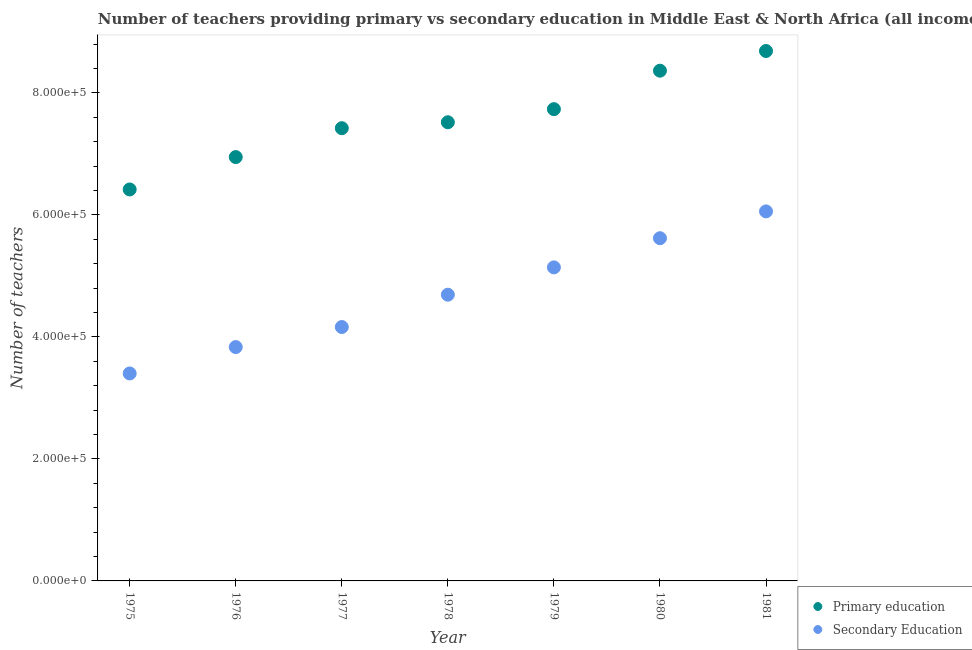Is the number of dotlines equal to the number of legend labels?
Offer a very short reply. Yes. What is the number of secondary teachers in 1978?
Keep it short and to the point. 4.69e+05. Across all years, what is the maximum number of primary teachers?
Ensure brevity in your answer.  8.69e+05. Across all years, what is the minimum number of primary teachers?
Keep it short and to the point. 6.42e+05. In which year was the number of secondary teachers maximum?
Offer a very short reply. 1981. In which year was the number of secondary teachers minimum?
Your answer should be compact. 1975. What is the total number of secondary teachers in the graph?
Your answer should be very brief. 3.29e+06. What is the difference between the number of primary teachers in 1977 and that in 1981?
Offer a terse response. -1.27e+05. What is the difference between the number of secondary teachers in 1980 and the number of primary teachers in 1977?
Ensure brevity in your answer.  -1.80e+05. What is the average number of primary teachers per year?
Give a very brief answer. 7.59e+05. In the year 1975, what is the difference between the number of secondary teachers and number of primary teachers?
Provide a short and direct response. -3.02e+05. In how many years, is the number of primary teachers greater than 560000?
Ensure brevity in your answer.  7. What is the ratio of the number of primary teachers in 1976 to that in 1979?
Provide a short and direct response. 0.9. Is the difference between the number of secondary teachers in 1979 and 1980 greater than the difference between the number of primary teachers in 1979 and 1980?
Provide a succinct answer. Yes. What is the difference between the highest and the second highest number of primary teachers?
Give a very brief answer. 3.23e+04. What is the difference between the highest and the lowest number of secondary teachers?
Your response must be concise. 2.66e+05. How many years are there in the graph?
Your answer should be compact. 7. Are the values on the major ticks of Y-axis written in scientific E-notation?
Your answer should be very brief. Yes. Where does the legend appear in the graph?
Offer a very short reply. Bottom right. How are the legend labels stacked?
Offer a very short reply. Vertical. What is the title of the graph?
Make the answer very short. Number of teachers providing primary vs secondary education in Middle East & North Africa (all income levels). What is the label or title of the X-axis?
Your response must be concise. Year. What is the label or title of the Y-axis?
Your answer should be very brief. Number of teachers. What is the Number of teachers in Primary education in 1975?
Keep it short and to the point. 6.42e+05. What is the Number of teachers in Secondary Education in 1975?
Keep it short and to the point. 3.40e+05. What is the Number of teachers in Primary education in 1976?
Offer a terse response. 6.95e+05. What is the Number of teachers in Secondary Education in 1976?
Your answer should be compact. 3.83e+05. What is the Number of teachers in Primary education in 1977?
Give a very brief answer. 7.42e+05. What is the Number of teachers of Secondary Education in 1977?
Ensure brevity in your answer.  4.16e+05. What is the Number of teachers of Primary education in 1978?
Provide a succinct answer. 7.52e+05. What is the Number of teachers in Secondary Education in 1978?
Your answer should be very brief. 4.69e+05. What is the Number of teachers of Primary education in 1979?
Offer a very short reply. 7.73e+05. What is the Number of teachers in Secondary Education in 1979?
Offer a terse response. 5.14e+05. What is the Number of teachers of Primary education in 1980?
Ensure brevity in your answer.  8.37e+05. What is the Number of teachers of Secondary Education in 1980?
Your answer should be very brief. 5.62e+05. What is the Number of teachers of Primary education in 1981?
Provide a short and direct response. 8.69e+05. What is the Number of teachers of Secondary Education in 1981?
Make the answer very short. 6.06e+05. Across all years, what is the maximum Number of teachers in Primary education?
Give a very brief answer. 8.69e+05. Across all years, what is the maximum Number of teachers of Secondary Education?
Make the answer very short. 6.06e+05. Across all years, what is the minimum Number of teachers in Primary education?
Offer a very short reply. 6.42e+05. Across all years, what is the minimum Number of teachers in Secondary Education?
Keep it short and to the point. 3.40e+05. What is the total Number of teachers in Primary education in the graph?
Give a very brief answer. 5.31e+06. What is the total Number of teachers in Secondary Education in the graph?
Offer a very short reply. 3.29e+06. What is the difference between the Number of teachers in Primary education in 1975 and that in 1976?
Your response must be concise. -5.31e+04. What is the difference between the Number of teachers of Secondary Education in 1975 and that in 1976?
Your answer should be compact. -4.32e+04. What is the difference between the Number of teachers in Primary education in 1975 and that in 1977?
Provide a succinct answer. -1.00e+05. What is the difference between the Number of teachers in Secondary Education in 1975 and that in 1977?
Ensure brevity in your answer.  -7.61e+04. What is the difference between the Number of teachers in Primary education in 1975 and that in 1978?
Your answer should be very brief. -1.10e+05. What is the difference between the Number of teachers of Secondary Education in 1975 and that in 1978?
Give a very brief answer. -1.29e+05. What is the difference between the Number of teachers in Primary education in 1975 and that in 1979?
Offer a very short reply. -1.32e+05. What is the difference between the Number of teachers in Secondary Education in 1975 and that in 1979?
Your answer should be compact. -1.74e+05. What is the difference between the Number of teachers in Primary education in 1975 and that in 1980?
Your response must be concise. -1.95e+05. What is the difference between the Number of teachers of Secondary Education in 1975 and that in 1980?
Provide a succinct answer. -2.22e+05. What is the difference between the Number of teachers of Primary education in 1975 and that in 1981?
Provide a succinct answer. -2.27e+05. What is the difference between the Number of teachers in Secondary Education in 1975 and that in 1981?
Give a very brief answer. -2.66e+05. What is the difference between the Number of teachers in Primary education in 1976 and that in 1977?
Make the answer very short. -4.74e+04. What is the difference between the Number of teachers of Secondary Education in 1976 and that in 1977?
Offer a terse response. -3.29e+04. What is the difference between the Number of teachers of Primary education in 1976 and that in 1978?
Make the answer very short. -5.71e+04. What is the difference between the Number of teachers of Secondary Education in 1976 and that in 1978?
Your answer should be very brief. -8.59e+04. What is the difference between the Number of teachers in Primary education in 1976 and that in 1979?
Your answer should be very brief. -7.86e+04. What is the difference between the Number of teachers in Secondary Education in 1976 and that in 1979?
Make the answer very short. -1.31e+05. What is the difference between the Number of teachers of Primary education in 1976 and that in 1980?
Provide a short and direct response. -1.42e+05. What is the difference between the Number of teachers in Secondary Education in 1976 and that in 1980?
Your answer should be very brief. -1.78e+05. What is the difference between the Number of teachers in Primary education in 1976 and that in 1981?
Your answer should be compact. -1.74e+05. What is the difference between the Number of teachers in Secondary Education in 1976 and that in 1981?
Your answer should be compact. -2.22e+05. What is the difference between the Number of teachers in Primary education in 1977 and that in 1978?
Ensure brevity in your answer.  -9722.06. What is the difference between the Number of teachers of Secondary Education in 1977 and that in 1978?
Ensure brevity in your answer.  -5.30e+04. What is the difference between the Number of teachers in Primary education in 1977 and that in 1979?
Ensure brevity in your answer.  -3.12e+04. What is the difference between the Number of teachers in Secondary Education in 1977 and that in 1979?
Offer a terse response. -9.78e+04. What is the difference between the Number of teachers of Primary education in 1977 and that in 1980?
Make the answer very short. -9.43e+04. What is the difference between the Number of teachers in Secondary Education in 1977 and that in 1980?
Keep it short and to the point. -1.46e+05. What is the difference between the Number of teachers of Primary education in 1977 and that in 1981?
Keep it short and to the point. -1.27e+05. What is the difference between the Number of teachers of Secondary Education in 1977 and that in 1981?
Provide a succinct answer. -1.90e+05. What is the difference between the Number of teachers of Primary education in 1978 and that in 1979?
Your answer should be compact. -2.15e+04. What is the difference between the Number of teachers in Secondary Education in 1978 and that in 1979?
Keep it short and to the point. -4.48e+04. What is the difference between the Number of teachers of Primary education in 1978 and that in 1980?
Your response must be concise. -8.45e+04. What is the difference between the Number of teachers of Secondary Education in 1978 and that in 1980?
Your response must be concise. -9.26e+04. What is the difference between the Number of teachers in Primary education in 1978 and that in 1981?
Offer a terse response. -1.17e+05. What is the difference between the Number of teachers of Secondary Education in 1978 and that in 1981?
Keep it short and to the point. -1.37e+05. What is the difference between the Number of teachers in Primary education in 1979 and that in 1980?
Your answer should be very brief. -6.31e+04. What is the difference between the Number of teachers in Secondary Education in 1979 and that in 1980?
Make the answer very short. -4.78e+04. What is the difference between the Number of teachers in Primary education in 1979 and that in 1981?
Keep it short and to the point. -9.54e+04. What is the difference between the Number of teachers of Secondary Education in 1979 and that in 1981?
Make the answer very short. -9.18e+04. What is the difference between the Number of teachers in Primary education in 1980 and that in 1981?
Offer a very short reply. -3.23e+04. What is the difference between the Number of teachers in Secondary Education in 1980 and that in 1981?
Your response must be concise. -4.40e+04. What is the difference between the Number of teachers of Primary education in 1975 and the Number of teachers of Secondary Education in 1976?
Your answer should be very brief. 2.58e+05. What is the difference between the Number of teachers in Primary education in 1975 and the Number of teachers in Secondary Education in 1977?
Offer a very short reply. 2.26e+05. What is the difference between the Number of teachers of Primary education in 1975 and the Number of teachers of Secondary Education in 1978?
Your answer should be compact. 1.73e+05. What is the difference between the Number of teachers in Primary education in 1975 and the Number of teachers in Secondary Education in 1979?
Provide a short and direct response. 1.28e+05. What is the difference between the Number of teachers of Primary education in 1975 and the Number of teachers of Secondary Education in 1980?
Your answer should be compact. 8.00e+04. What is the difference between the Number of teachers in Primary education in 1975 and the Number of teachers in Secondary Education in 1981?
Provide a succinct answer. 3.60e+04. What is the difference between the Number of teachers in Primary education in 1976 and the Number of teachers in Secondary Education in 1977?
Your answer should be very brief. 2.79e+05. What is the difference between the Number of teachers of Primary education in 1976 and the Number of teachers of Secondary Education in 1978?
Offer a very short reply. 2.26e+05. What is the difference between the Number of teachers of Primary education in 1976 and the Number of teachers of Secondary Education in 1979?
Make the answer very short. 1.81e+05. What is the difference between the Number of teachers of Primary education in 1976 and the Number of teachers of Secondary Education in 1980?
Ensure brevity in your answer.  1.33e+05. What is the difference between the Number of teachers of Primary education in 1976 and the Number of teachers of Secondary Education in 1981?
Provide a succinct answer. 8.91e+04. What is the difference between the Number of teachers in Primary education in 1977 and the Number of teachers in Secondary Education in 1978?
Your answer should be compact. 2.73e+05. What is the difference between the Number of teachers of Primary education in 1977 and the Number of teachers of Secondary Education in 1979?
Make the answer very short. 2.28e+05. What is the difference between the Number of teachers of Primary education in 1977 and the Number of teachers of Secondary Education in 1980?
Your answer should be compact. 1.80e+05. What is the difference between the Number of teachers in Primary education in 1977 and the Number of teachers in Secondary Education in 1981?
Provide a short and direct response. 1.36e+05. What is the difference between the Number of teachers of Primary education in 1978 and the Number of teachers of Secondary Education in 1979?
Your answer should be very brief. 2.38e+05. What is the difference between the Number of teachers in Primary education in 1978 and the Number of teachers in Secondary Education in 1980?
Your response must be concise. 1.90e+05. What is the difference between the Number of teachers in Primary education in 1978 and the Number of teachers in Secondary Education in 1981?
Your response must be concise. 1.46e+05. What is the difference between the Number of teachers of Primary education in 1979 and the Number of teachers of Secondary Education in 1980?
Make the answer very short. 2.12e+05. What is the difference between the Number of teachers of Primary education in 1979 and the Number of teachers of Secondary Education in 1981?
Make the answer very short. 1.68e+05. What is the difference between the Number of teachers in Primary education in 1980 and the Number of teachers in Secondary Education in 1981?
Keep it short and to the point. 2.31e+05. What is the average Number of teachers of Primary education per year?
Your response must be concise. 7.59e+05. What is the average Number of teachers of Secondary Education per year?
Offer a very short reply. 4.70e+05. In the year 1975, what is the difference between the Number of teachers in Primary education and Number of teachers in Secondary Education?
Keep it short and to the point. 3.02e+05. In the year 1976, what is the difference between the Number of teachers of Primary education and Number of teachers of Secondary Education?
Offer a very short reply. 3.12e+05. In the year 1977, what is the difference between the Number of teachers in Primary education and Number of teachers in Secondary Education?
Give a very brief answer. 3.26e+05. In the year 1978, what is the difference between the Number of teachers in Primary education and Number of teachers in Secondary Education?
Make the answer very short. 2.83e+05. In the year 1979, what is the difference between the Number of teachers of Primary education and Number of teachers of Secondary Education?
Offer a terse response. 2.59e+05. In the year 1980, what is the difference between the Number of teachers of Primary education and Number of teachers of Secondary Education?
Provide a short and direct response. 2.75e+05. In the year 1981, what is the difference between the Number of teachers in Primary education and Number of teachers in Secondary Education?
Offer a very short reply. 2.63e+05. What is the ratio of the Number of teachers in Primary education in 1975 to that in 1976?
Ensure brevity in your answer.  0.92. What is the ratio of the Number of teachers in Secondary Education in 1975 to that in 1976?
Your answer should be compact. 0.89. What is the ratio of the Number of teachers of Primary education in 1975 to that in 1977?
Your answer should be very brief. 0.86. What is the ratio of the Number of teachers of Secondary Education in 1975 to that in 1977?
Your answer should be compact. 0.82. What is the ratio of the Number of teachers in Primary education in 1975 to that in 1978?
Keep it short and to the point. 0.85. What is the ratio of the Number of teachers of Secondary Education in 1975 to that in 1978?
Your answer should be compact. 0.72. What is the ratio of the Number of teachers in Primary education in 1975 to that in 1979?
Offer a terse response. 0.83. What is the ratio of the Number of teachers in Secondary Education in 1975 to that in 1979?
Your response must be concise. 0.66. What is the ratio of the Number of teachers of Primary education in 1975 to that in 1980?
Keep it short and to the point. 0.77. What is the ratio of the Number of teachers of Secondary Education in 1975 to that in 1980?
Ensure brevity in your answer.  0.61. What is the ratio of the Number of teachers of Primary education in 1975 to that in 1981?
Offer a terse response. 0.74. What is the ratio of the Number of teachers in Secondary Education in 1975 to that in 1981?
Your response must be concise. 0.56. What is the ratio of the Number of teachers in Primary education in 1976 to that in 1977?
Give a very brief answer. 0.94. What is the ratio of the Number of teachers of Secondary Education in 1976 to that in 1977?
Give a very brief answer. 0.92. What is the ratio of the Number of teachers of Primary education in 1976 to that in 1978?
Your answer should be very brief. 0.92. What is the ratio of the Number of teachers in Secondary Education in 1976 to that in 1978?
Give a very brief answer. 0.82. What is the ratio of the Number of teachers of Primary education in 1976 to that in 1979?
Offer a very short reply. 0.9. What is the ratio of the Number of teachers in Secondary Education in 1976 to that in 1979?
Provide a succinct answer. 0.75. What is the ratio of the Number of teachers in Primary education in 1976 to that in 1980?
Your answer should be very brief. 0.83. What is the ratio of the Number of teachers in Secondary Education in 1976 to that in 1980?
Make the answer very short. 0.68. What is the ratio of the Number of teachers in Primary education in 1976 to that in 1981?
Your answer should be compact. 0.8. What is the ratio of the Number of teachers of Secondary Education in 1976 to that in 1981?
Provide a succinct answer. 0.63. What is the ratio of the Number of teachers in Primary education in 1977 to that in 1978?
Your answer should be compact. 0.99. What is the ratio of the Number of teachers of Secondary Education in 1977 to that in 1978?
Offer a very short reply. 0.89. What is the ratio of the Number of teachers in Primary education in 1977 to that in 1979?
Ensure brevity in your answer.  0.96. What is the ratio of the Number of teachers of Secondary Education in 1977 to that in 1979?
Provide a short and direct response. 0.81. What is the ratio of the Number of teachers of Primary education in 1977 to that in 1980?
Your answer should be very brief. 0.89. What is the ratio of the Number of teachers of Secondary Education in 1977 to that in 1980?
Your answer should be very brief. 0.74. What is the ratio of the Number of teachers in Primary education in 1977 to that in 1981?
Give a very brief answer. 0.85. What is the ratio of the Number of teachers of Secondary Education in 1977 to that in 1981?
Offer a terse response. 0.69. What is the ratio of the Number of teachers in Primary education in 1978 to that in 1979?
Provide a succinct answer. 0.97. What is the ratio of the Number of teachers of Secondary Education in 1978 to that in 1979?
Provide a succinct answer. 0.91. What is the ratio of the Number of teachers in Primary education in 1978 to that in 1980?
Keep it short and to the point. 0.9. What is the ratio of the Number of teachers of Secondary Education in 1978 to that in 1980?
Provide a succinct answer. 0.84. What is the ratio of the Number of teachers of Primary education in 1978 to that in 1981?
Your answer should be very brief. 0.87. What is the ratio of the Number of teachers in Secondary Education in 1978 to that in 1981?
Offer a very short reply. 0.77. What is the ratio of the Number of teachers of Primary education in 1979 to that in 1980?
Your response must be concise. 0.92. What is the ratio of the Number of teachers of Secondary Education in 1979 to that in 1980?
Your response must be concise. 0.91. What is the ratio of the Number of teachers of Primary education in 1979 to that in 1981?
Provide a succinct answer. 0.89. What is the ratio of the Number of teachers in Secondary Education in 1979 to that in 1981?
Provide a succinct answer. 0.85. What is the ratio of the Number of teachers in Primary education in 1980 to that in 1981?
Keep it short and to the point. 0.96. What is the ratio of the Number of teachers in Secondary Education in 1980 to that in 1981?
Offer a very short reply. 0.93. What is the difference between the highest and the second highest Number of teachers in Primary education?
Provide a short and direct response. 3.23e+04. What is the difference between the highest and the second highest Number of teachers in Secondary Education?
Your answer should be compact. 4.40e+04. What is the difference between the highest and the lowest Number of teachers of Primary education?
Give a very brief answer. 2.27e+05. What is the difference between the highest and the lowest Number of teachers of Secondary Education?
Give a very brief answer. 2.66e+05. 